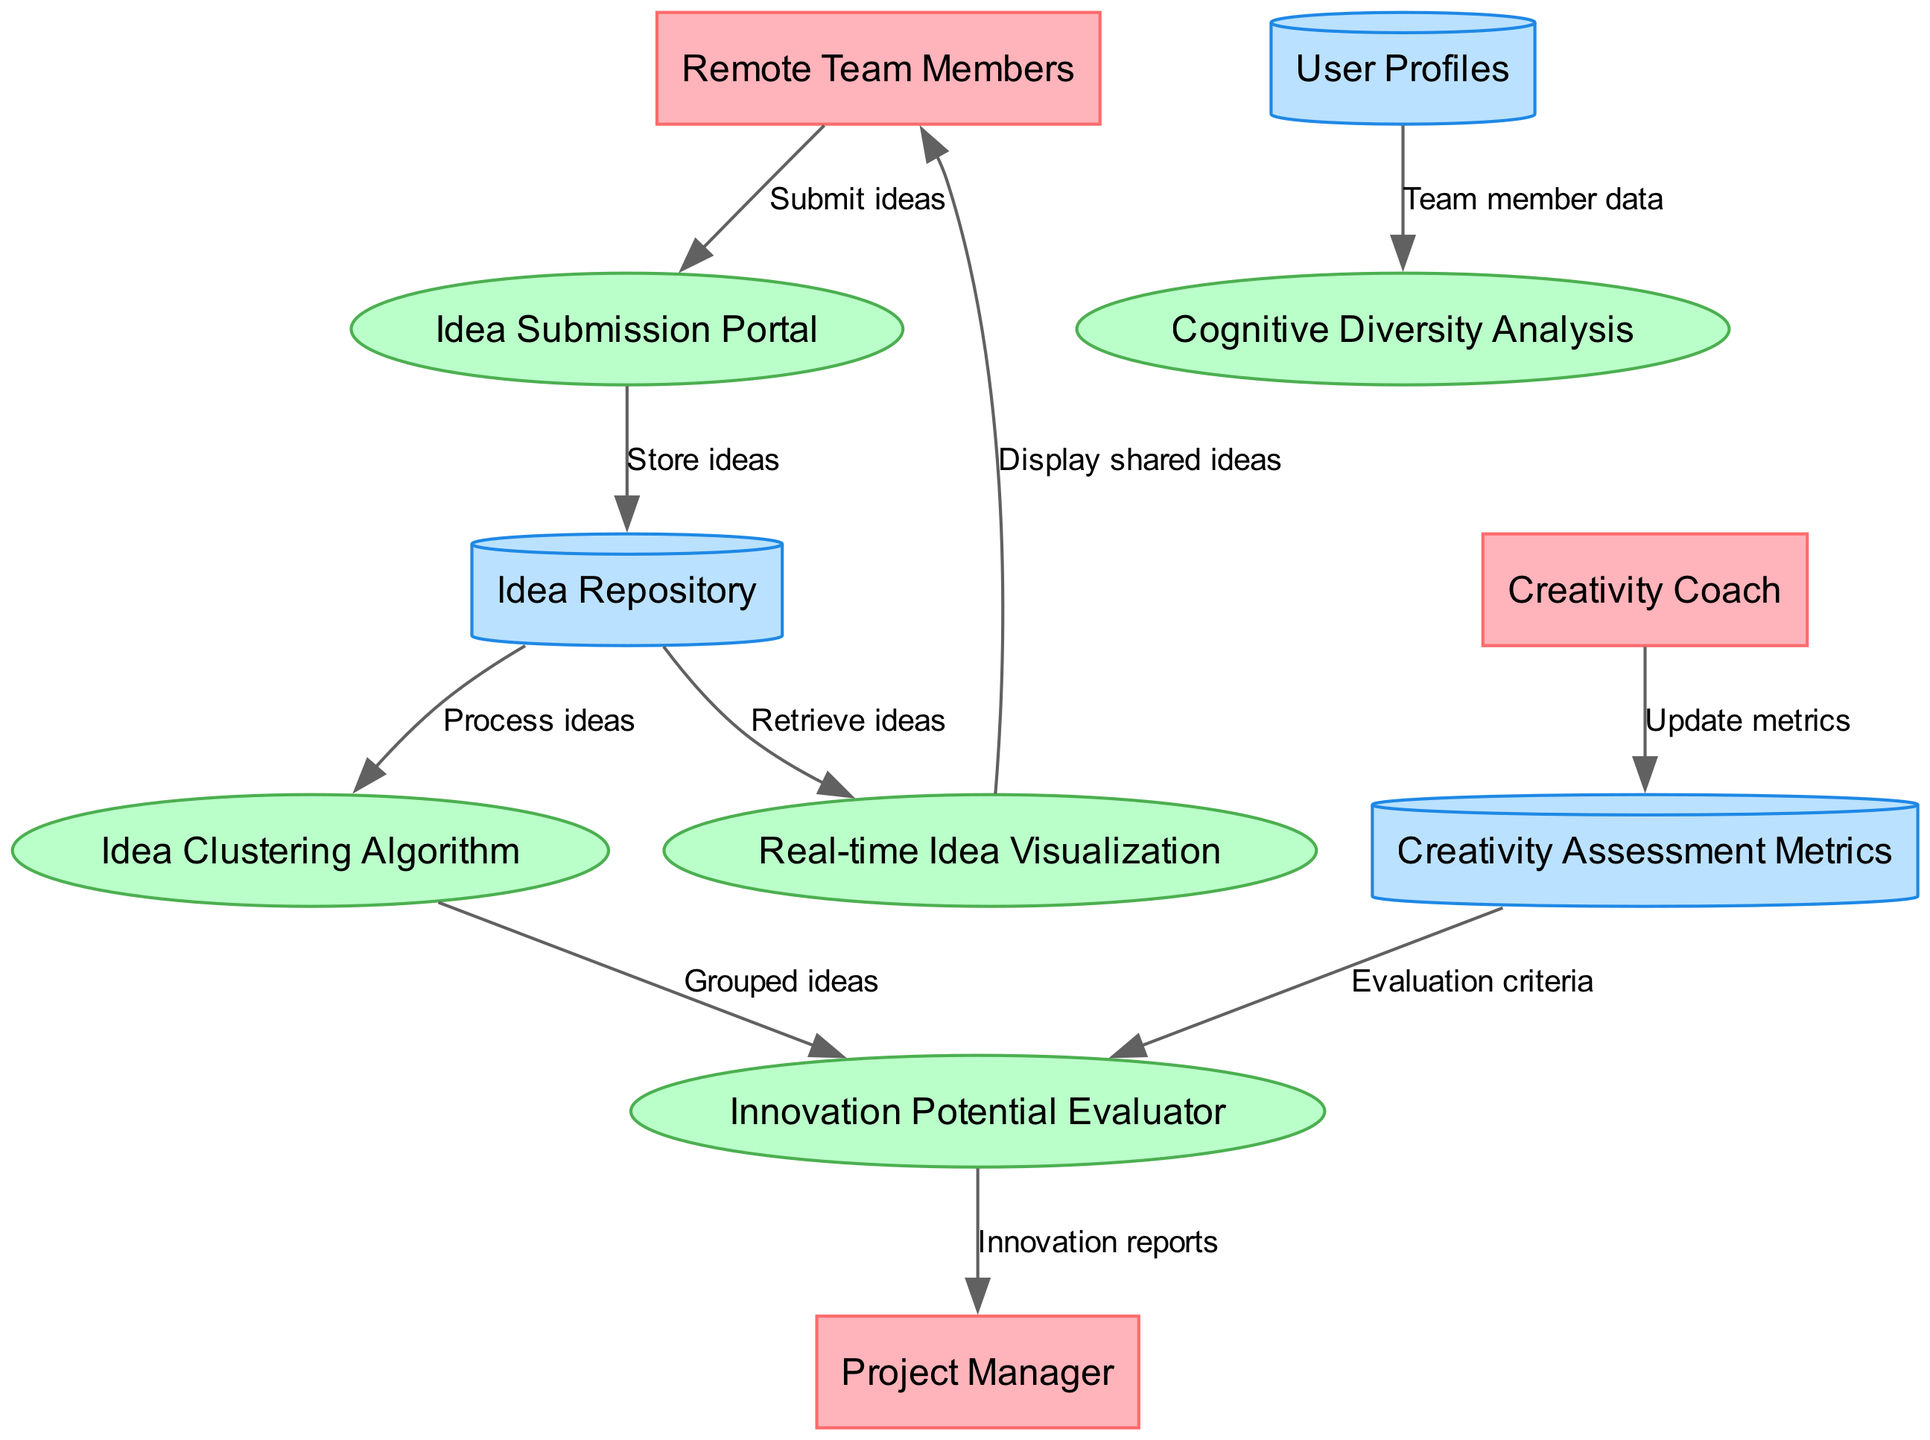What are the external entities in the diagram? The external entities are listed at the top of the Data Flow Diagram and include "Remote Team Members," "Project Manager," and "Creativity Coach." These are the participants interacting with the processes.
Answer: Remote Team Members, Project Manager, Creativity Coach How many processes are depicted in the diagram? The diagram includes five distinct processes outlined in the center section. They are "Idea Submission Portal," "Real-time Idea Visualization," "Cognitive Diversity Analysis," "Idea Clustering Algorithm," and "Innovation Potential Evaluator."
Answer: 5 What data flows from the Idea Submission Portal to the Idea Repository? The data flow from the Idea Submission Portal to the Idea Repository is labeled "Store ideas," indicating that the ideas submitted are stored in the repository for further processing.
Answer: Store ideas Which process uses team member data from User Profiles? The process that utilizes team member data from User Profiles is "Cognitive Diversity Analysis." This indicates it analyzes the diversity within the team based on individual profiles.
Answer: Cognitive Diversity Analysis What is the output of the Innovation Potential Evaluator to the Project Manager? The output of the Innovation Potential Evaluator to the Project Manager is labeled "Innovation reports." This shows that the reports summarizing the evaluated ideas are sent directly to the Project Manager for review.
Answer: Innovation reports Which external entity updates the Creativity Assessment Metrics? The external entity responsible for updating the Creativity Assessment Metrics is the "Creativity Coach." They are involved in maintaining the metrics that assess creativity within the team.
Answer: Creativity Coach Describe the relationship between the Idea Clustering Algorithm and the Innovation Potential Evaluator. The Idea Clustering Algorithm sends "Grouped ideas" to the Innovation Potential Evaluator, indicating that it processes and organizes the ideas before they are evaluated for their innovation potential.
Answer: Grouped ideas How many data stores are present in the diagram? There are three data stores represented in the diagram, which are "Idea Repository," "User Profiles," and "Creativity Assessment Metrics." These are where the information is stored for access by the processes.
Answer: 3 What does the Real-time Idea Visualization display to Remote Team Members? The Real-time Idea Visualization displays "shared ideas" to Remote Team Members, providing a dynamic view of ideas collected in the system for collaborative brainstorming.
Answer: Display shared ideas 